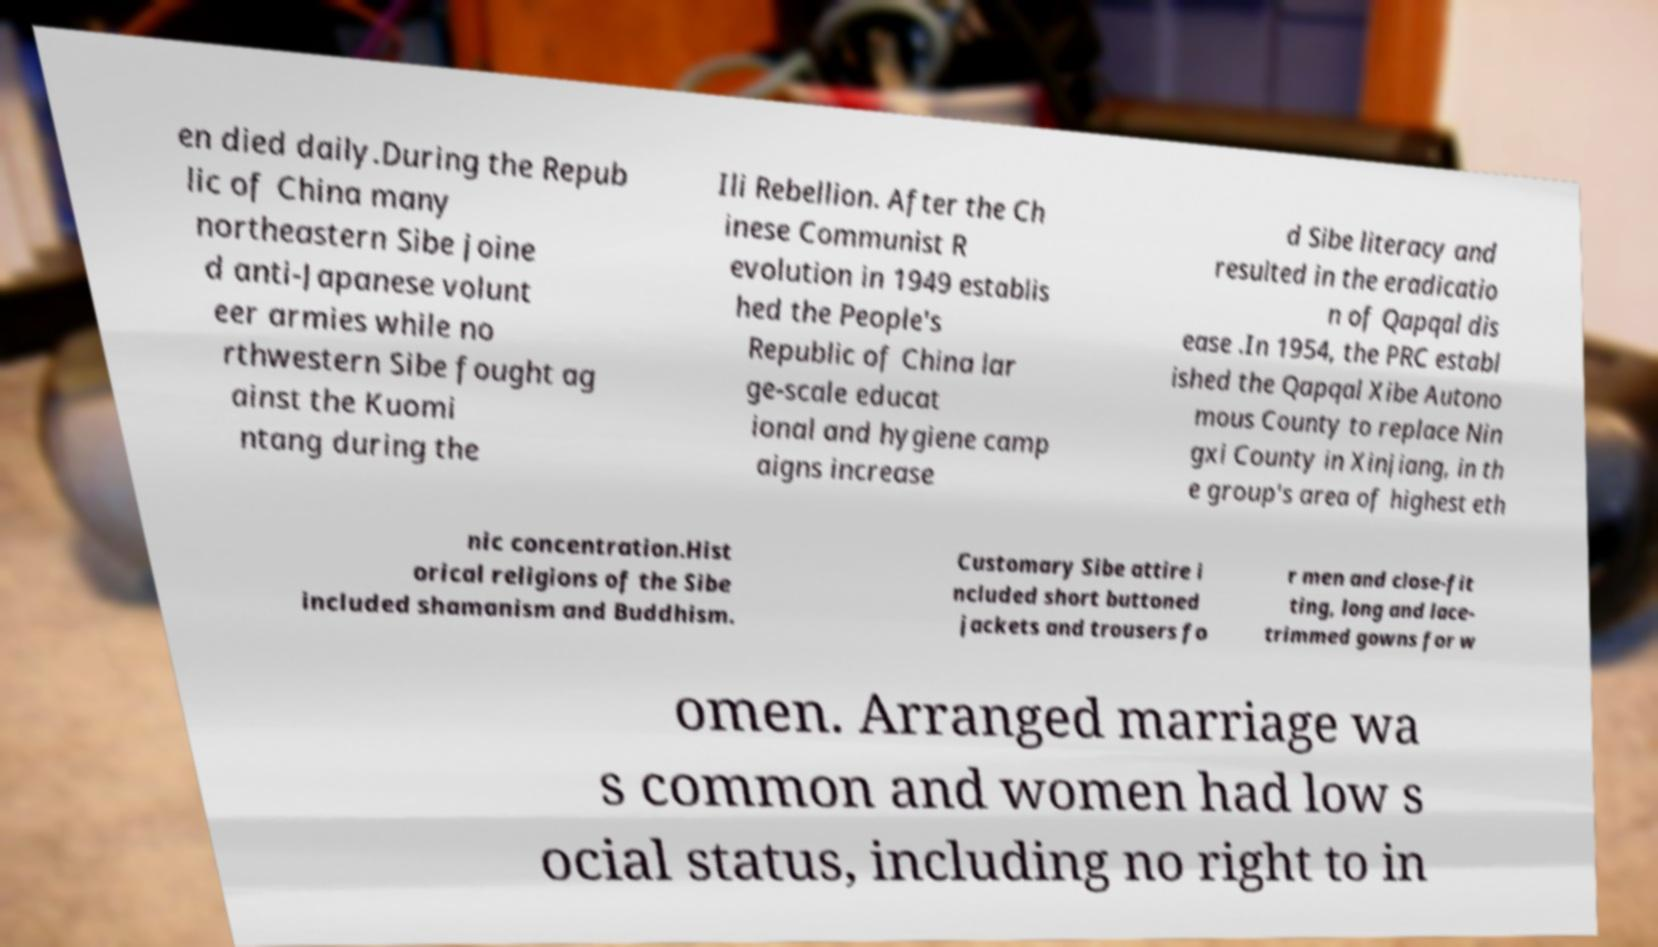There's text embedded in this image that I need extracted. Can you transcribe it verbatim? en died daily.During the Repub lic of China many northeastern Sibe joine d anti-Japanese volunt eer armies while no rthwestern Sibe fought ag ainst the Kuomi ntang during the Ili Rebellion. After the Ch inese Communist R evolution in 1949 establis hed the People's Republic of China lar ge-scale educat ional and hygiene camp aigns increase d Sibe literacy and resulted in the eradicatio n of Qapqal dis ease .In 1954, the PRC establ ished the Qapqal Xibe Autono mous County to replace Nin gxi County in Xinjiang, in th e group's area of highest eth nic concentration.Hist orical religions of the Sibe included shamanism and Buddhism. Customary Sibe attire i ncluded short buttoned jackets and trousers fo r men and close-fit ting, long and lace- trimmed gowns for w omen. Arranged marriage wa s common and women had low s ocial status, including no right to in 